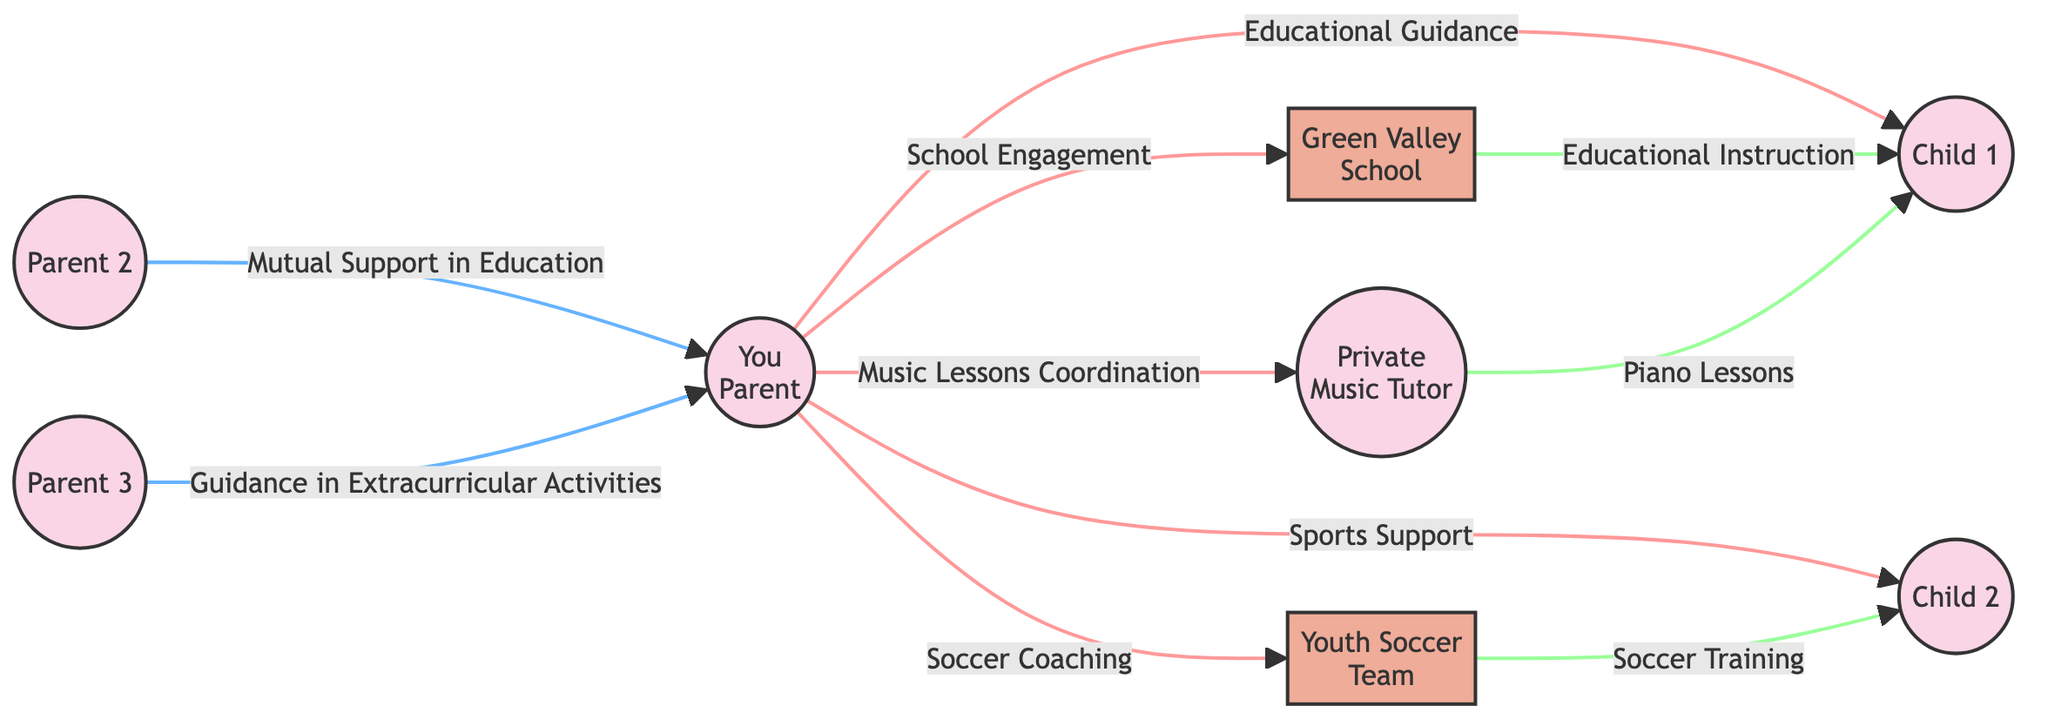What is the total number of nodes in the diagram? Count the distinct individual and institution nodes listed in the data. The nodes include You (Parent), Child 1, Child 2, Green Valley School, Youth Soccer Team, Private Music Tutor, Parent 2, and Parent 3, totaling eight nodes.
Answer: 8 Who provides Educational Guidance to Child 1? Trace the connection from Child 1 and see which node points to it. The edge from You (Parent) to Child 1 indicates that the guidance is provided by You (Parent).
Answer: You (Parent) Which institution is involved in providing Soccer Training to Child 2? Look for the edge leading to Child 2; the arrow shows that Youth Soccer Team is the institution linked to Child 2 for Soccer Training.
Answer: Youth Soccer Team How many support relationships are represented in the diagram? Analyze the edges and classify them based on their labels. The edges labeled "Sports Support," "Mutual Support in Education," and "Guidance in Extracurricular Activities" are the support relationships, totaling three support edges.
Answer: 3 Which individual coordinates Music Lessons for Child 1? Identify who is connected to Child 1 in terms of music lessons. The edge labeled "Music Lessons Coordination" from You (Parent) to Private Music Tutor indicates that You (Parent) coordinates the lessons for Child 1.
Answer: You (Parent) What type of engagement does You (Parent) have with Green Valley School? Check the edge from You (Parent) to Green Valley School; it is labeled "School Engagement," indicating an engaged relationship.
Answer: School Engagement Who offers guidance in extracurricular activities? Locate the directed edge that indicates guidance; it shows that Parent 3 provides the guidance in this area towards You (Parent), who may share this with others.
Answer: Parent 3 How many edges represent direct support from You (Parent) to children? Look for edges that connect You (Parent) directly to Child 1 and Child 2 indicating support. The edges are "Educational Guidance" to Child 1 and "Sports Support" to Child 2, resulting in two direct support edges.
Answer: 2 What type of instruction does Green Valley School provide? Identify the edge leading from the school to Child 1; the label reads "Educational Instruction," showing the nature of the instruction offered.
Answer: Educational Instruction 